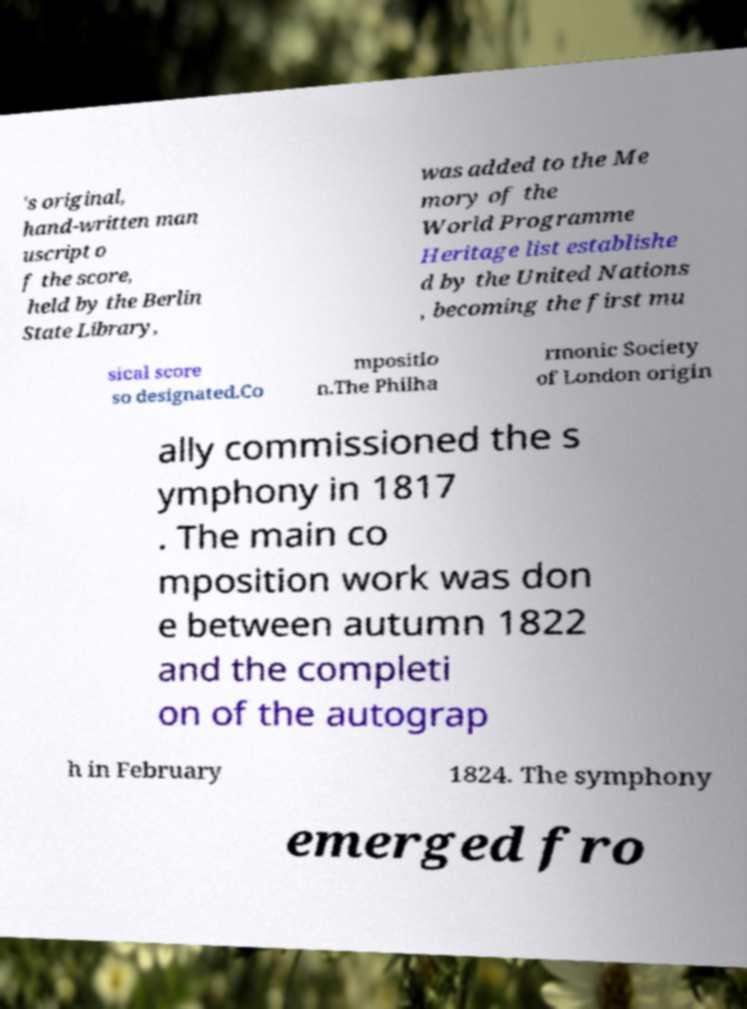Please identify and transcribe the text found in this image. 's original, hand-written man uscript o f the score, held by the Berlin State Library, was added to the Me mory of the World Programme Heritage list establishe d by the United Nations , becoming the first mu sical score so designated.Co mpositio n.The Philha rmonic Society of London origin ally commissioned the s ymphony in 1817 . The main co mposition work was don e between autumn 1822 and the completi on of the autograp h in February 1824. The symphony emerged fro 